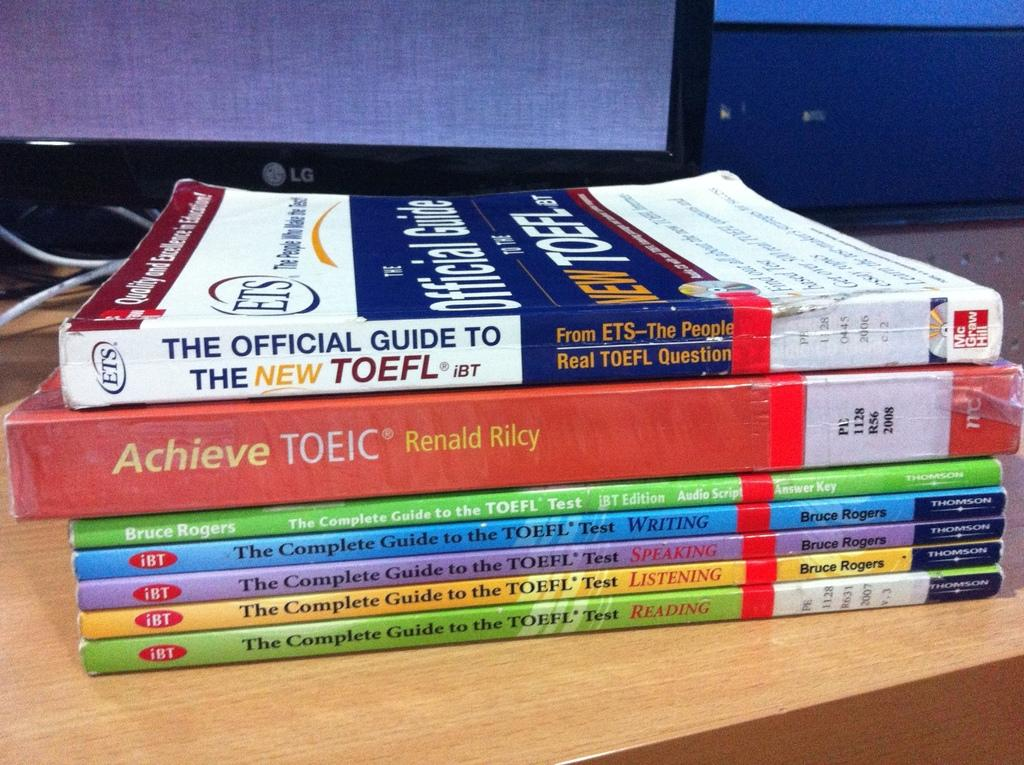Provide a one-sentence caption for the provided image. The TOEFL test can be prepared for using specialized study books. 